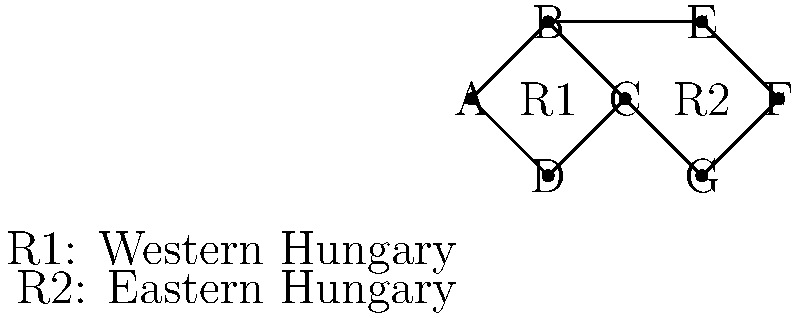Consider the graph representing Hungary's economic regions and their interconnections. Regions are represented by vertices, and economic links between regions are represented by edges. The graph is divided into two main areas: R1 (Western Hungary) and R2 (Eastern Hungary). What is the minimum number of economic links (edges) that need to be removed to completely separate R1 from R2, assuming that vertices A, B, C, and D belong to R1, while E, F, and G belong to R2? To solve this problem, we need to apply the concept of graph connectivity and the min-cut theorem. Here's a step-by-step approach:

1. Identify the regions:
   R1 (Western Hungary): Vertices A, B, C, D
   R2 (Eastern Hungary): Vertices E, F, G

2. Identify all connections between R1 and R2:
   B -- E
   C -- F
   C -- G

3. Count the number of these connections:
   There are 3 edges connecting R1 and R2.

4. Apply the min-cut theorem:
   The minimum number of edges that need to be removed to disconnect two parts of a graph is equal to the minimum cut between those parts.

5. Verify that removing these 3 edges will indeed separate R1 from R2:
   If we remove B -- E, C -- F, and C -- G, there will be no remaining connections between R1 and R2.

6. Check if there's a smaller cut:
   There is no way to separate R1 from R2 by removing fewer than 3 edges, as each of the connecting edges is the only path between some vertices in R1 and R2.

Therefore, the minimum number of economic links that need to be removed to completely separate R1 from R2 is 3.
Answer: 3 